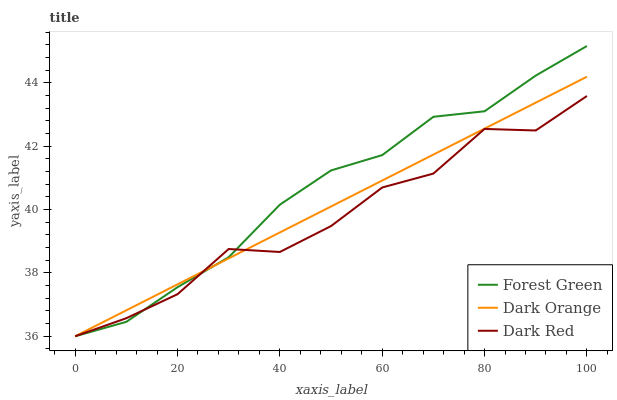Does Dark Red have the minimum area under the curve?
Answer yes or no. Yes. Does Forest Green have the maximum area under the curve?
Answer yes or no. Yes. Does Forest Green have the minimum area under the curve?
Answer yes or no. No. Does Dark Red have the maximum area under the curve?
Answer yes or no. No. Is Dark Orange the smoothest?
Answer yes or no. Yes. Is Dark Red the roughest?
Answer yes or no. Yes. Is Forest Green the smoothest?
Answer yes or no. No. Is Forest Green the roughest?
Answer yes or no. No. Does Forest Green have the highest value?
Answer yes or no. Yes. Does Dark Red have the highest value?
Answer yes or no. No. Does Forest Green intersect Dark Orange?
Answer yes or no. Yes. Is Forest Green less than Dark Orange?
Answer yes or no. No. Is Forest Green greater than Dark Orange?
Answer yes or no. No. 